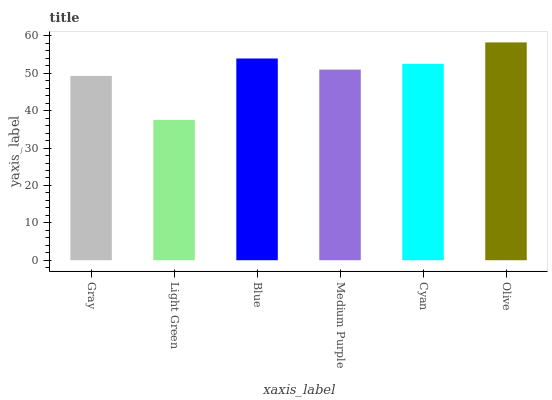Is Light Green the minimum?
Answer yes or no. Yes. Is Olive the maximum?
Answer yes or no. Yes. Is Blue the minimum?
Answer yes or no. No. Is Blue the maximum?
Answer yes or no. No. Is Blue greater than Light Green?
Answer yes or no. Yes. Is Light Green less than Blue?
Answer yes or no. Yes. Is Light Green greater than Blue?
Answer yes or no. No. Is Blue less than Light Green?
Answer yes or no. No. Is Cyan the high median?
Answer yes or no. Yes. Is Medium Purple the low median?
Answer yes or no. Yes. Is Medium Purple the high median?
Answer yes or no. No. Is Light Green the low median?
Answer yes or no. No. 